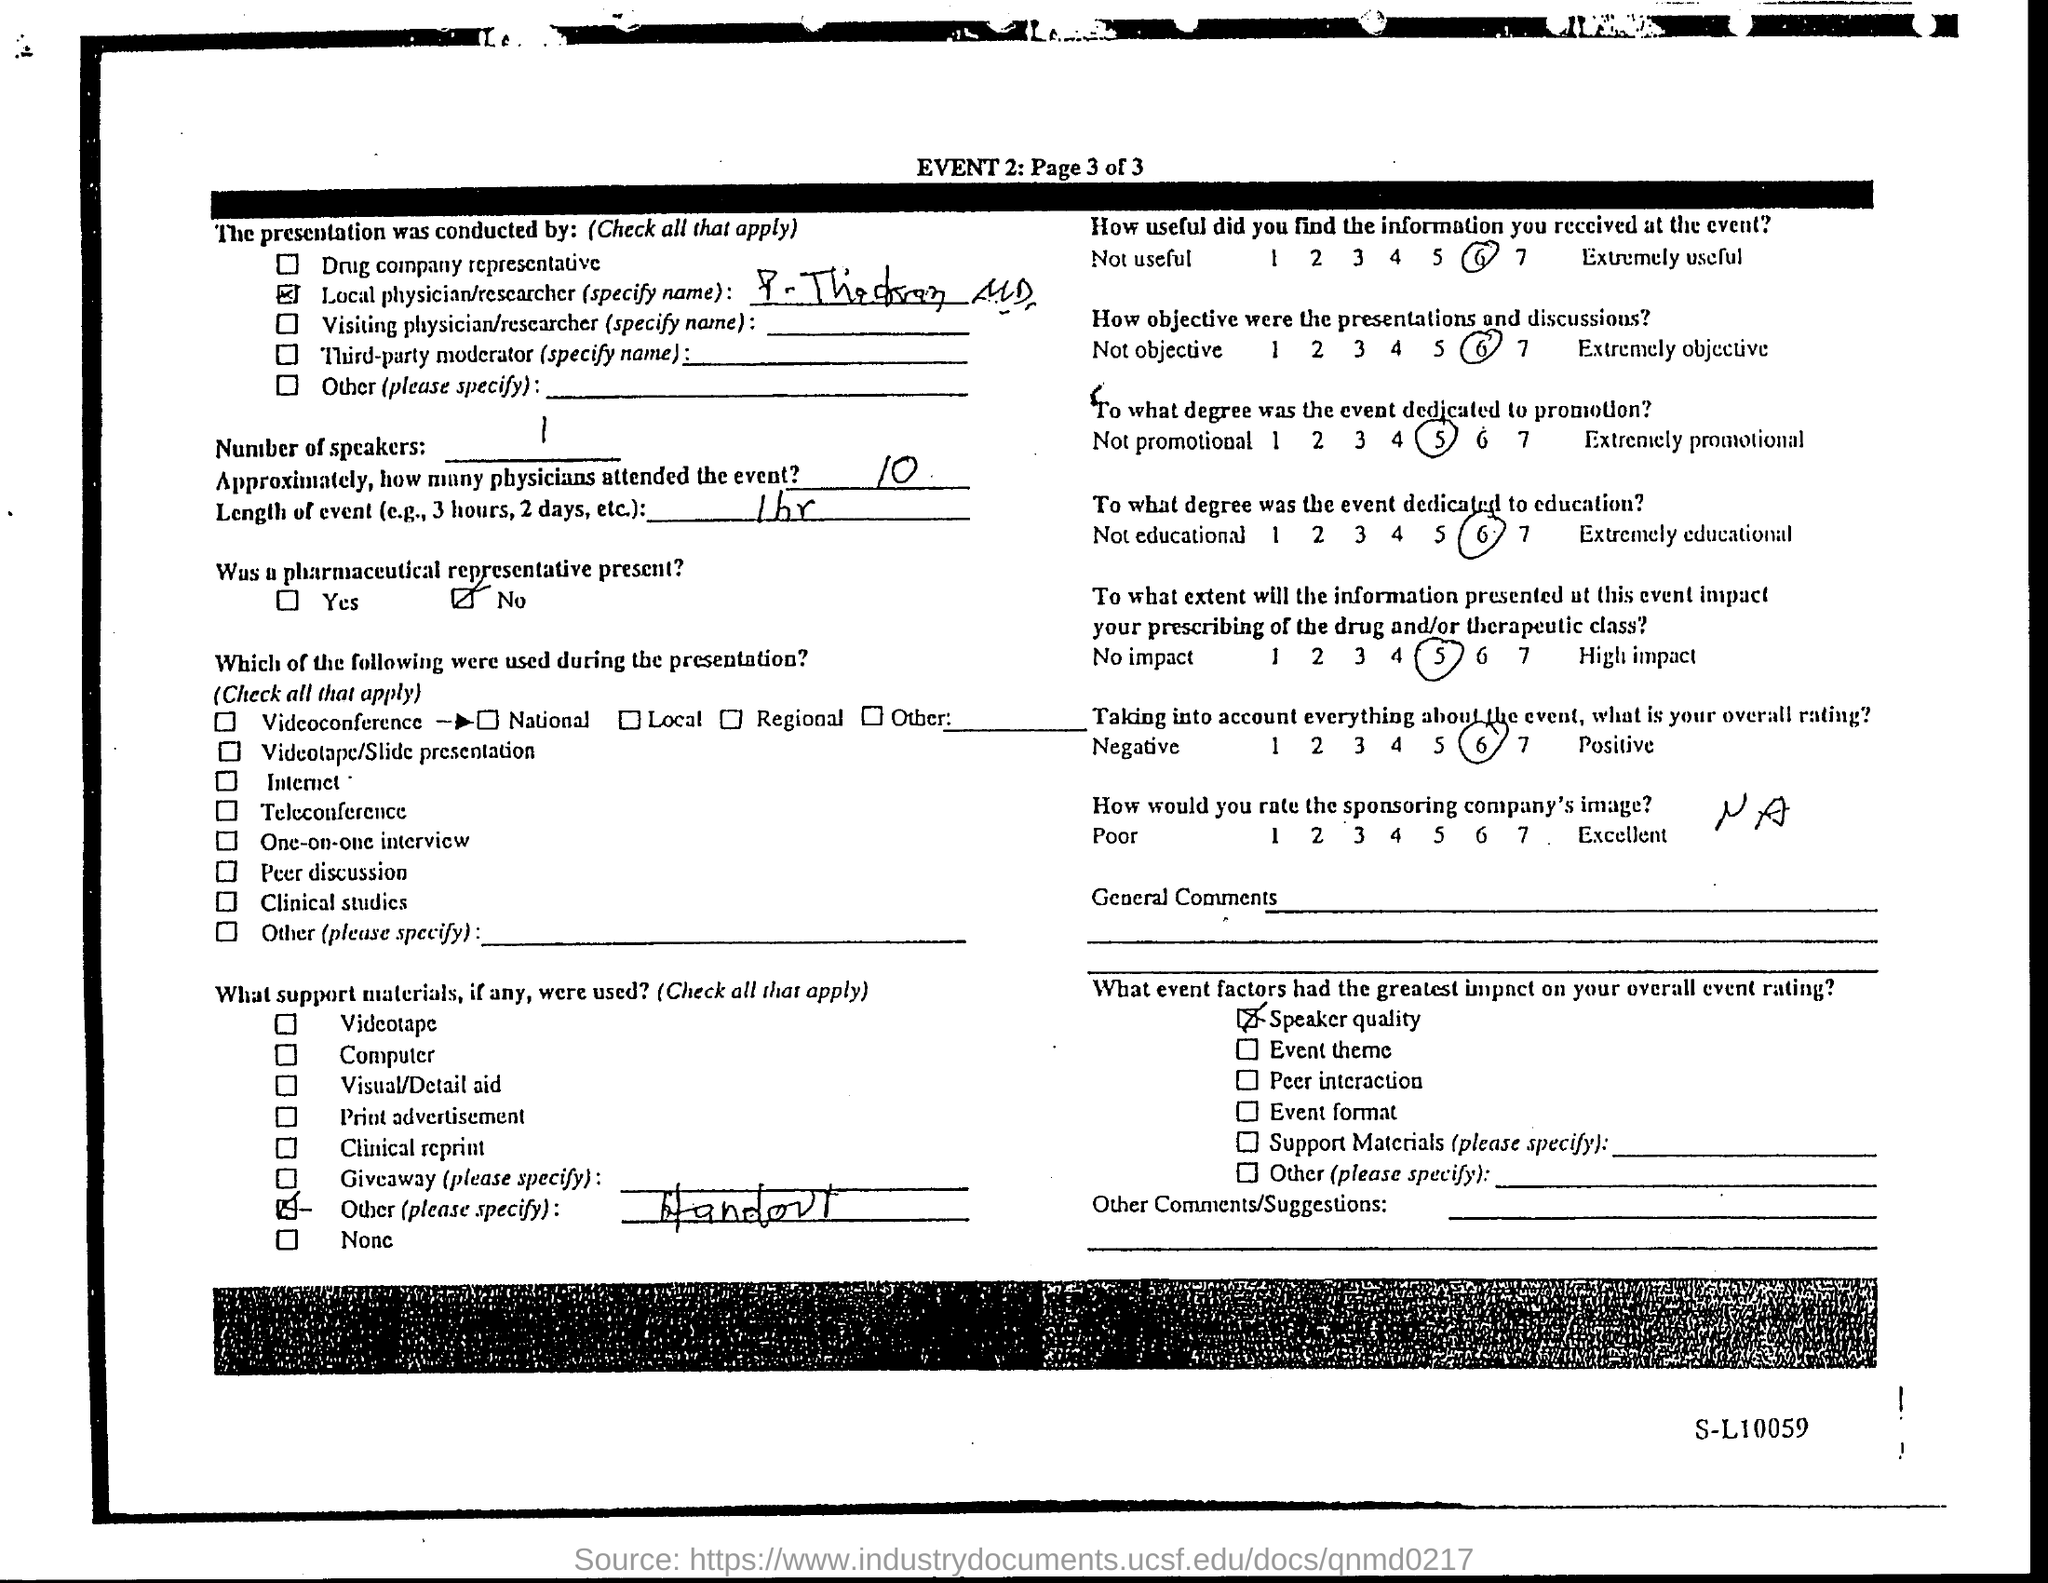Highlight a few significant elements in this photo. The rating given for the usefulness of the information received at the event is 6. The overall rating of the event was largely influenced by the quality of the speakers. Approximately 10 physicians attended the event. It was reported that the individual in question was not present as a pharmaceutical representative. The length of the event is one hour. 